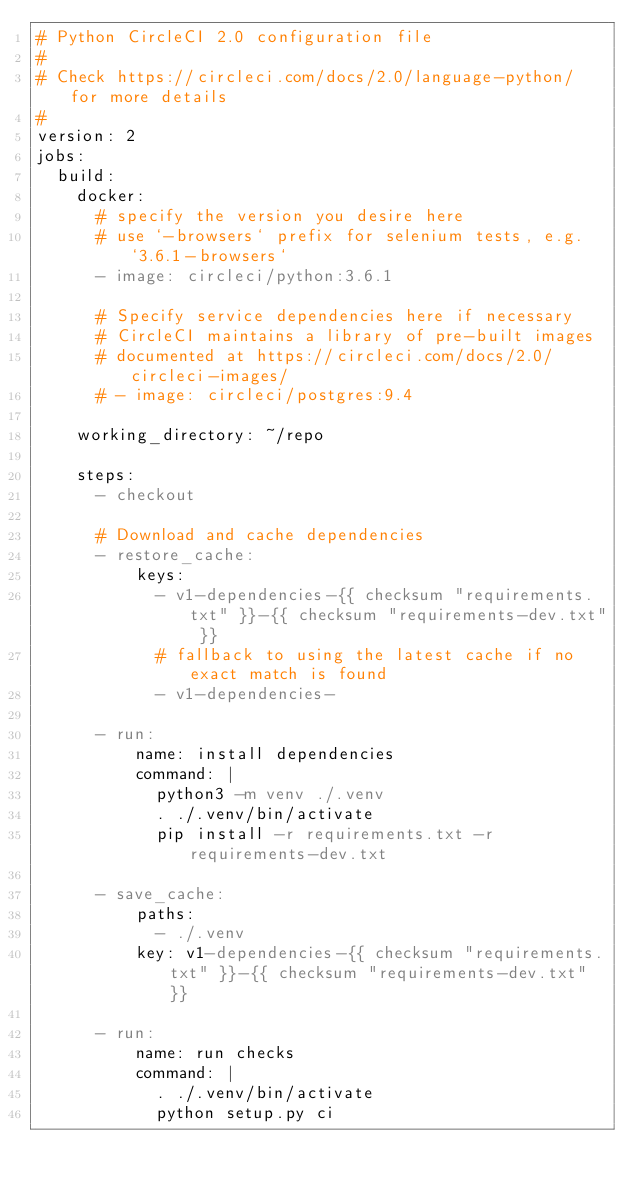<code> <loc_0><loc_0><loc_500><loc_500><_YAML_># Python CircleCI 2.0 configuration file
#
# Check https://circleci.com/docs/2.0/language-python/ for more details
#
version: 2
jobs:
  build:
    docker:
      # specify the version you desire here
      # use `-browsers` prefix for selenium tests, e.g. `3.6.1-browsers`
      - image: circleci/python:3.6.1

      # Specify service dependencies here if necessary
      # CircleCI maintains a library of pre-built images
      # documented at https://circleci.com/docs/2.0/circleci-images/
      # - image: circleci/postgres:9.4

    working_directory: ~/repo

    steps:
      - checkout

      # Download and cache dependencies
      - restore_cache:
          keys:
            - v1-dependencies-{{ checksum "requirements.txt" }}-{{ checksum "requirements-dev.txt" }}
            # fallback to using the latest cache if no exact match is found
            - v1-dependencies-

      - run:
          name: install dependencies
          command: |
            python3 -m venv ./.venv
            . ./.venv/bin/activate
            pip install -r requirements.txt -r requirements-dev.txt

      - save_cache:
          paths:
            - ./.venv
          key: v1-dependencies-{{ checksum "requirements.txt" }}-{{ checksum "requirements-dev.txt" }}

      - run:
          name: run checks
          command: |
            . ./.venv/bin/activate
            python setup.py ci</code> 